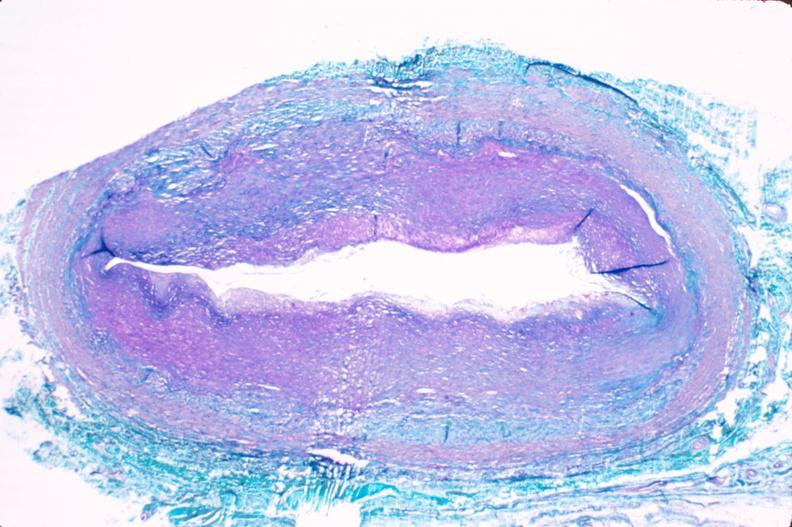does chronic ischemia show saphenous vein graft sclerosis?
Answer the question using a single word or phrase. No 